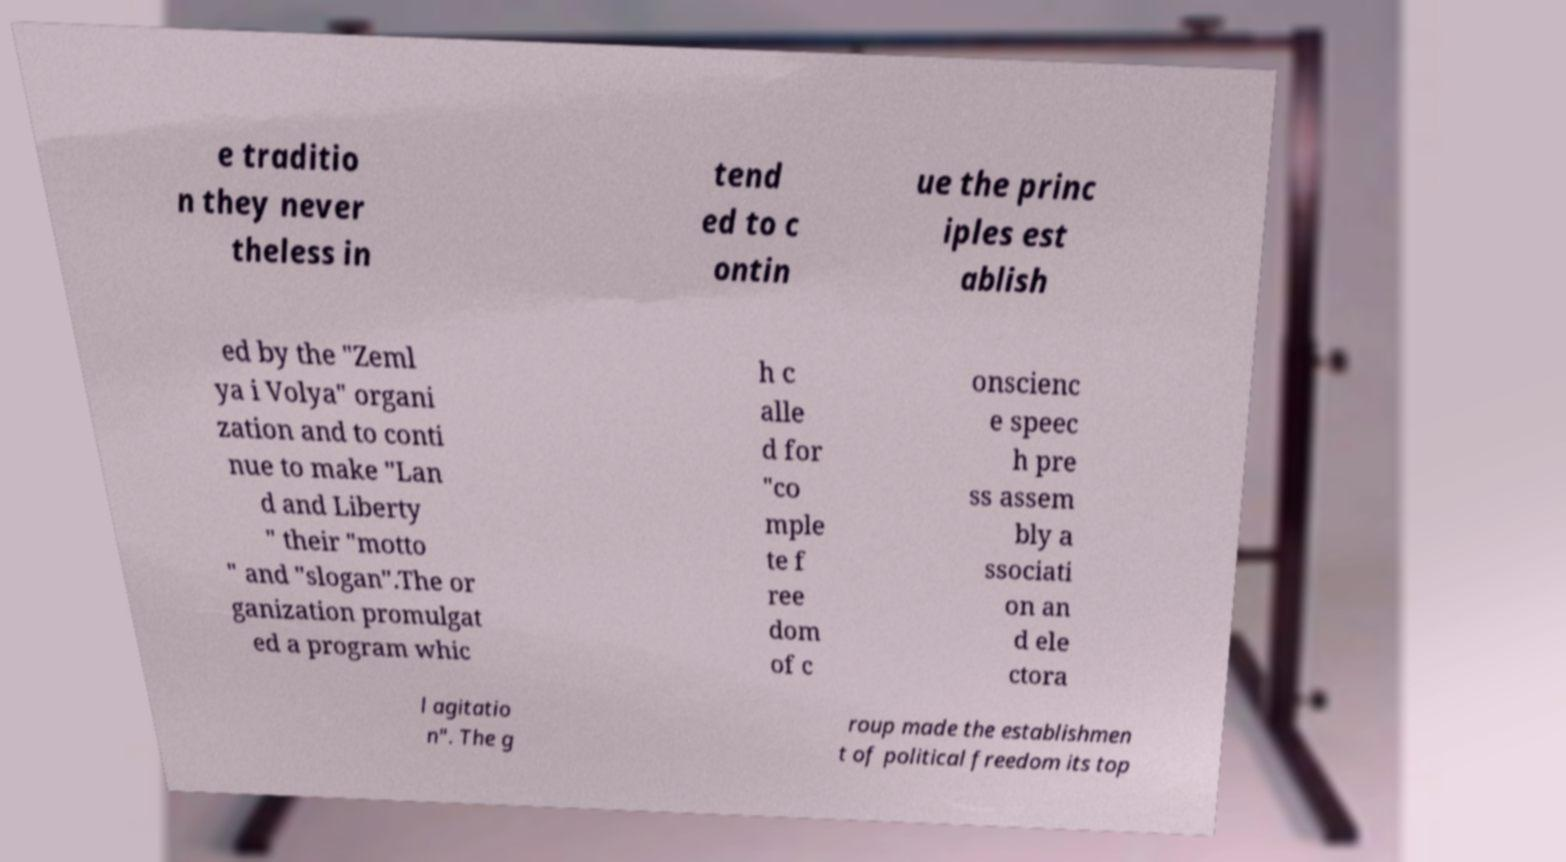For documentation purposes, I need the text within this image transcribed. Could you provide that? e traditio n they never theless in tend ed to c ontin ue the princ iples est ablish ed by the "Zeml ya i Volya" organi zation and to conti nue to make "Lan d and Liberty " their "motto " and "slogan".The or ganization promulgat ed a program whic h c alle d for "co mple te f ree dom of c onscienc e speec h pre ss assem bly a ssociati on an d ele ctora l agitatio n". The g roup made the establishmen t of political freedom its top 